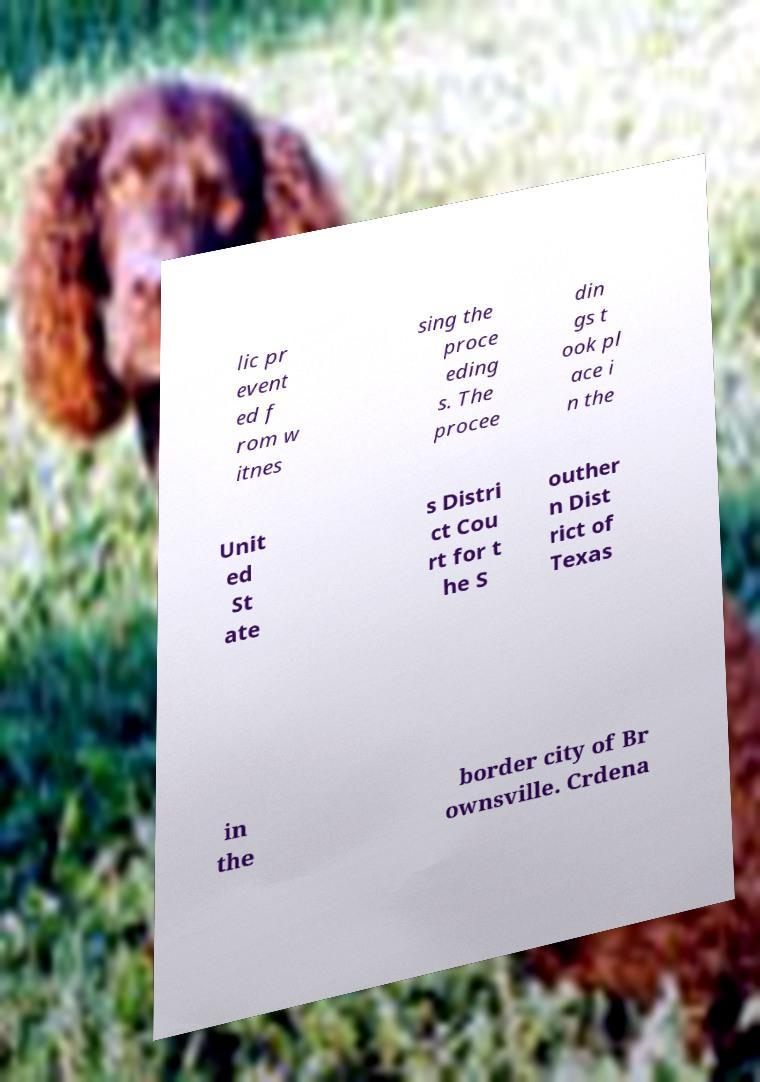Please identify and transcribe the text found in this image. lic pr event ed f rom w itnes sing the proce eding s. The procee din gs t ook pl ace i n the Unit ed St ate s Distri ct Cou rt for t he S outher n Dist rict of Texas in the border city of Br ownsville. Crdena 